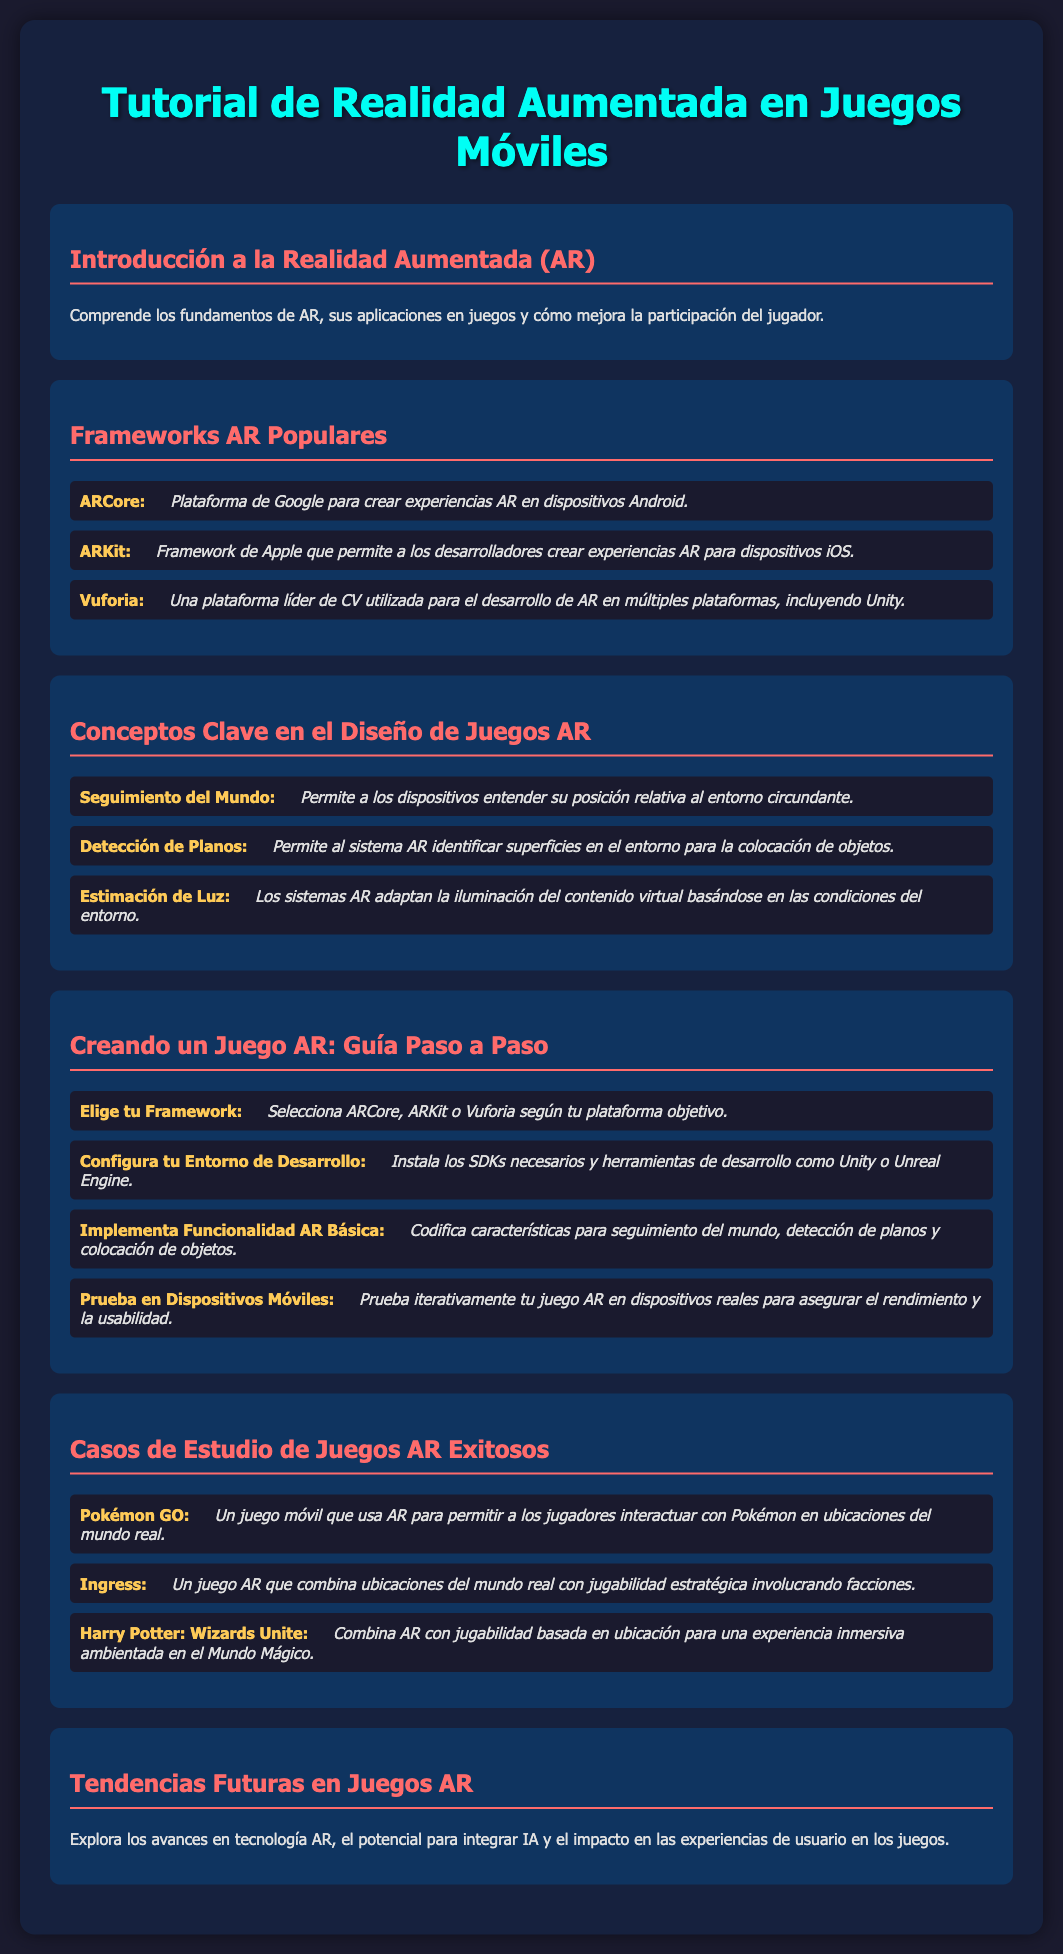¿Cuál es el título del tutorial? El título del documento se encuentra en la parte superior del contenido.
Answer: Tutorial de Realidad Aumentada en Juegos Móviles ¿Cuáles son los frameworks AR populares mencionados? Los frameworks AR populares se listan en la sección correspondiente, incluyendo sus descripciones.
Answer: ARCore, ARKit, Vuforia ¿Qué permite el "Seguimiento del Mundo"? Esta es una característica clave en el diseño de juegos AR que permite que los dispositivos entiendan su posición relativa.
Answer: Entender su posición relativa al entorno circundante ¿Qué es el primer paso para crear un juego AR? La guía paso a paso comienza con la elección de un framework adecuado.
Answer: Elegir tu Framework Nombre un juego AR exitoso mencionado en el documento. La sección de casos de estudio incluye varios ejemplos de juegos AR.
Answer: Pokémon GO ¿Cuál es una tendencia futura en los juegos AR? La última sección del documento aborda las tendencias futuras en el ámbito de los juegos AR.
Answer: Avances en tecnología AR ¿Qué se debe hacer para probar un juego AR? La guía indica que se debe probar iterativamente en dispositivos reales.
Answer: Probar en Dispositivos Móviles ¿Qué lenguaje se utiliza para la descripción del contenido? Se determina por la declaración del documento, indicando el idioma utilizado para presentar la información.
Answer: Español 